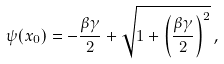<formula> <loc_0><loc_0><loc_500><loc_500>\psi ( x _ { 0 } ) = - \frac { \beta \gamma } { 2 } + \sqrt { 1 + \left ( \frac { \beta \gamma } { 2 } \right ) ^ { 2 } } \, ,</formula> 